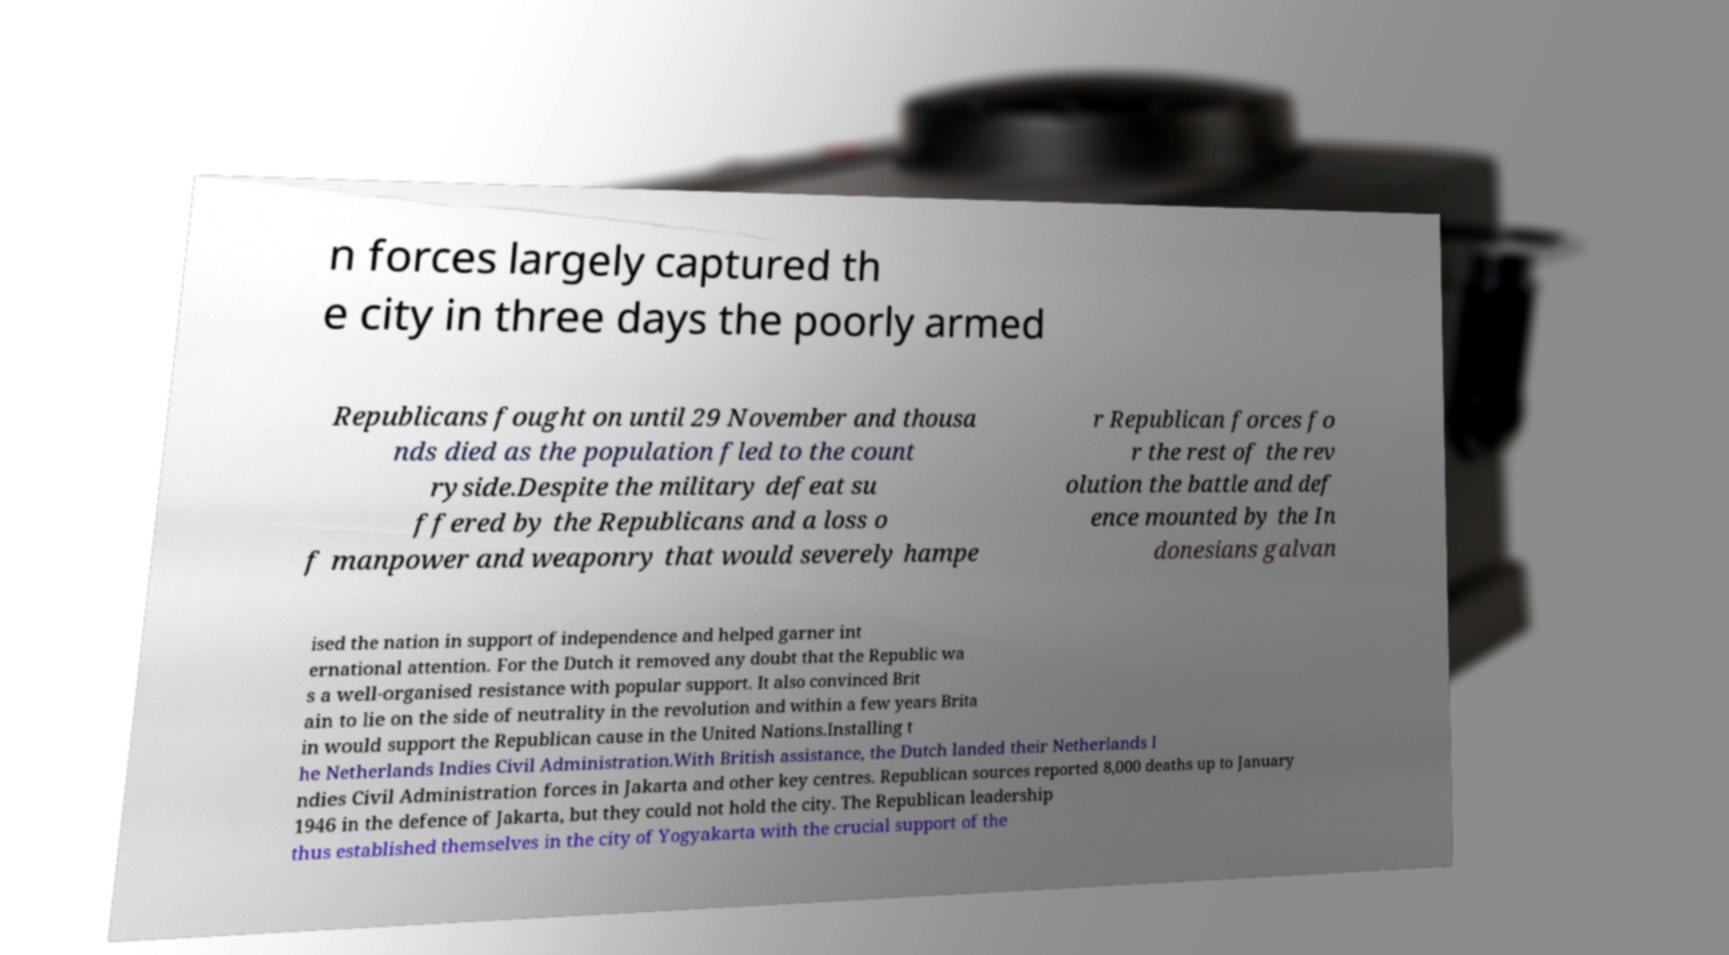I need the written content from this picture converted into text. Can you do that? n forces largely captured th e city in three days the poorly armed Republicans fought on until 29 November and thousa nds died as the population fled to the count ryside.Despite the military defeat su ffered by the Republicans and a loss o f manpower and weaponry that would severely hampe r Republican forces fo r the rest of the rev olution the battle and def ence mounted by the In donesians galvan ised the nation in support of independence and helped garner int ernational attention. For the Dutch it removed any doubt that the Republic wa s a well-organised resistance with popular support. It also convinced Brit ain to lie on the side of neutrality in the revolution and within a few years Brita in would support the Republican cause in the United Nations.Installing t he Netherlands Indies Civil Administration.With British assistance, the Dutch landed their Netherlands I ndies Civil Administration forces in Jakarta and other key centres. Republican sources reported 8,000 deaths up to January 1946 in the defence of Jakarta, but they could not hold the city. The Republican leadership thus established themselves in the city of Yogyakarta with the crucial support of the 